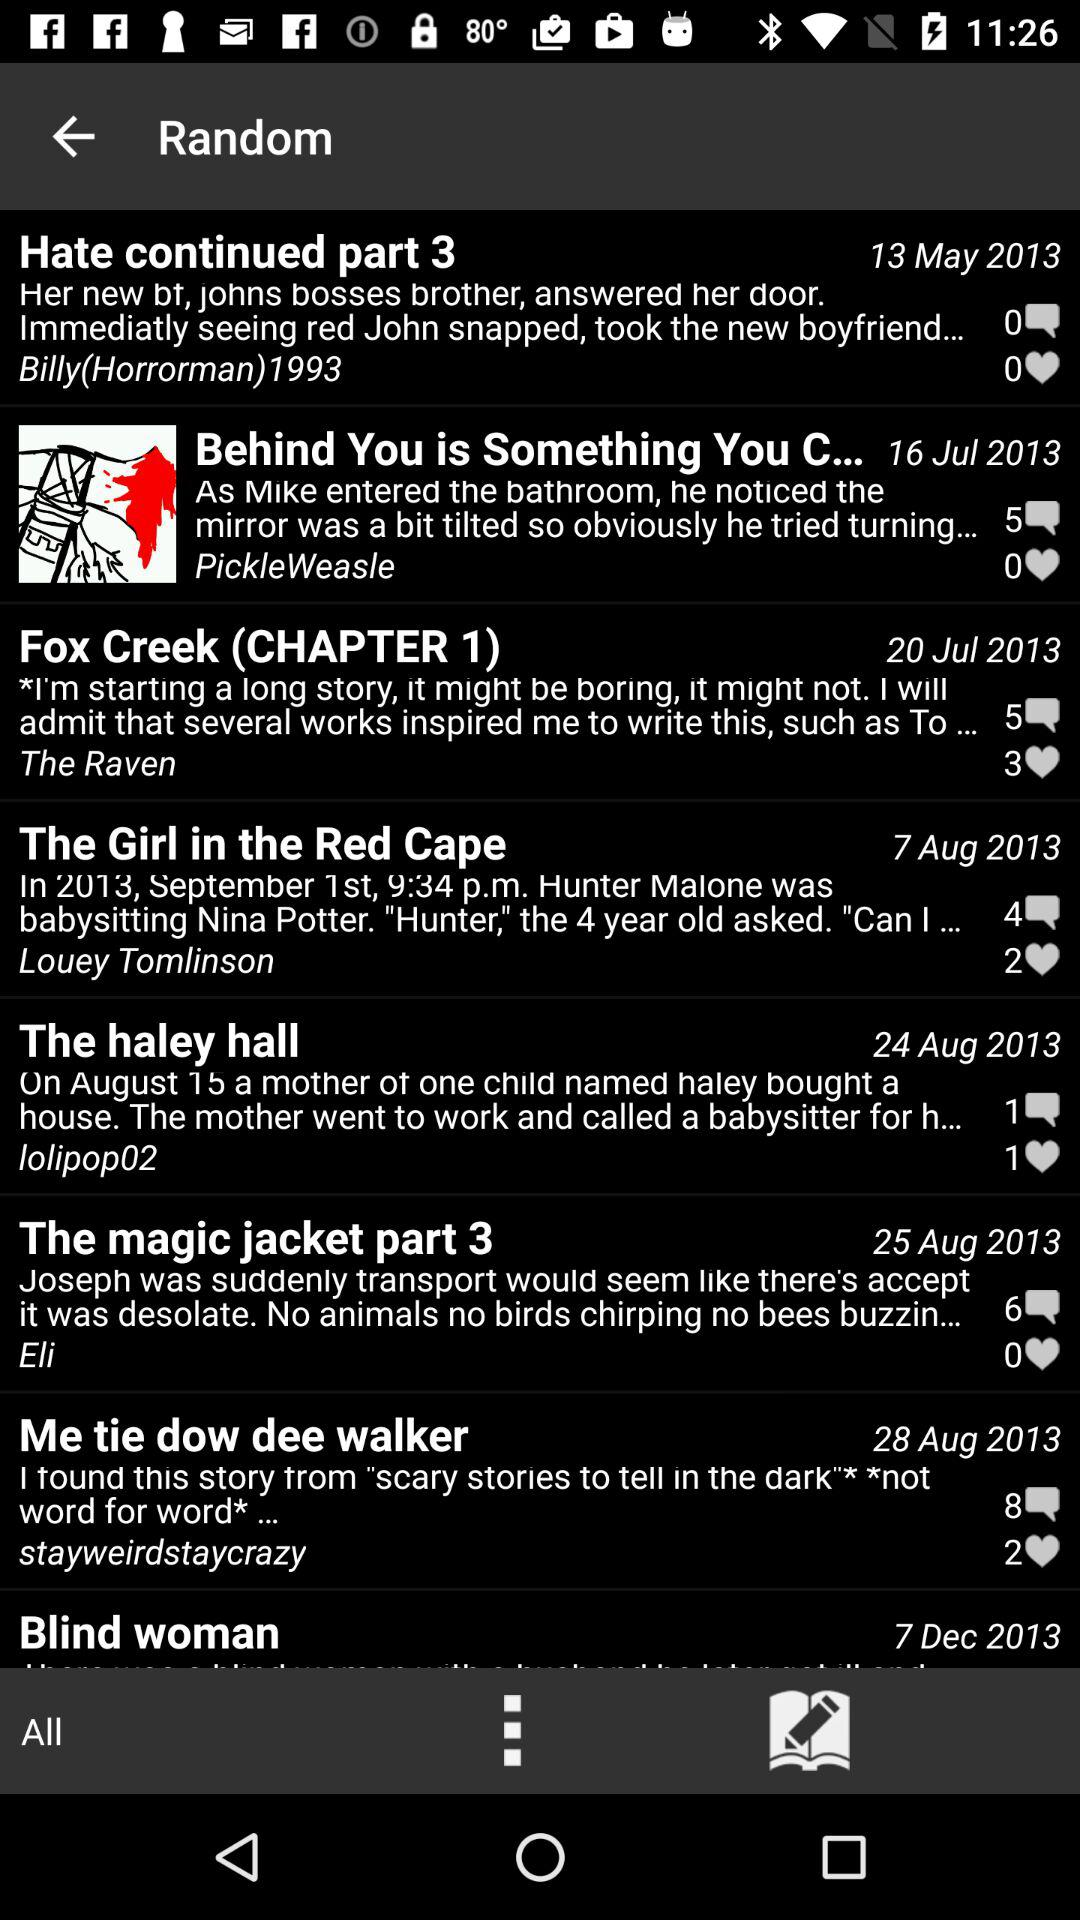How many comments are there for "The haley hall" post? There is 1 comment for "The haley hall" post. 